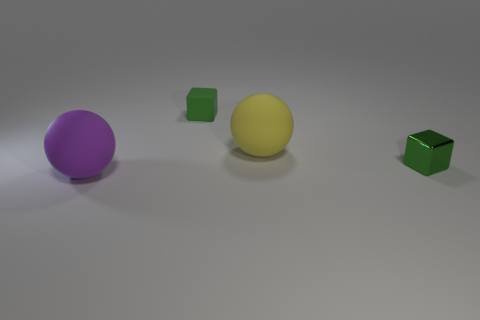Is the yellow sphere made of the same material as the purple object?
Make the answer very short. Yes. What number of objects are in front of the yellow matte object and right of the tiny green rubber cube?
Keep it short and to the point. 1. How many other things are the same color as the shiny cube?
Make the answer very short. 1. What number of yellow objects are either rubber blocks or cubes?
Provide a succinct answer. 0. How big is the green metal block?
Provide a short and direct response. Small. What number of rubber objects are either large yellow things or blocks?
Your response must be concise. 2. Are there fewer large purple rubber spheres than brown rubber cylinders?
Ensure brevity in your answer.  No. What number of other objects are there of the same material as the big yellow object?
Your answer should be compact. 2. There is a purple rubber object that is the same shape as the big yellow thing; what size is it?
Your answer should be compact. Large. Is the green object behind the green metal cube made of the same material as the big thing that is in front of the metallic block?
Offer a terse response. Yes. 